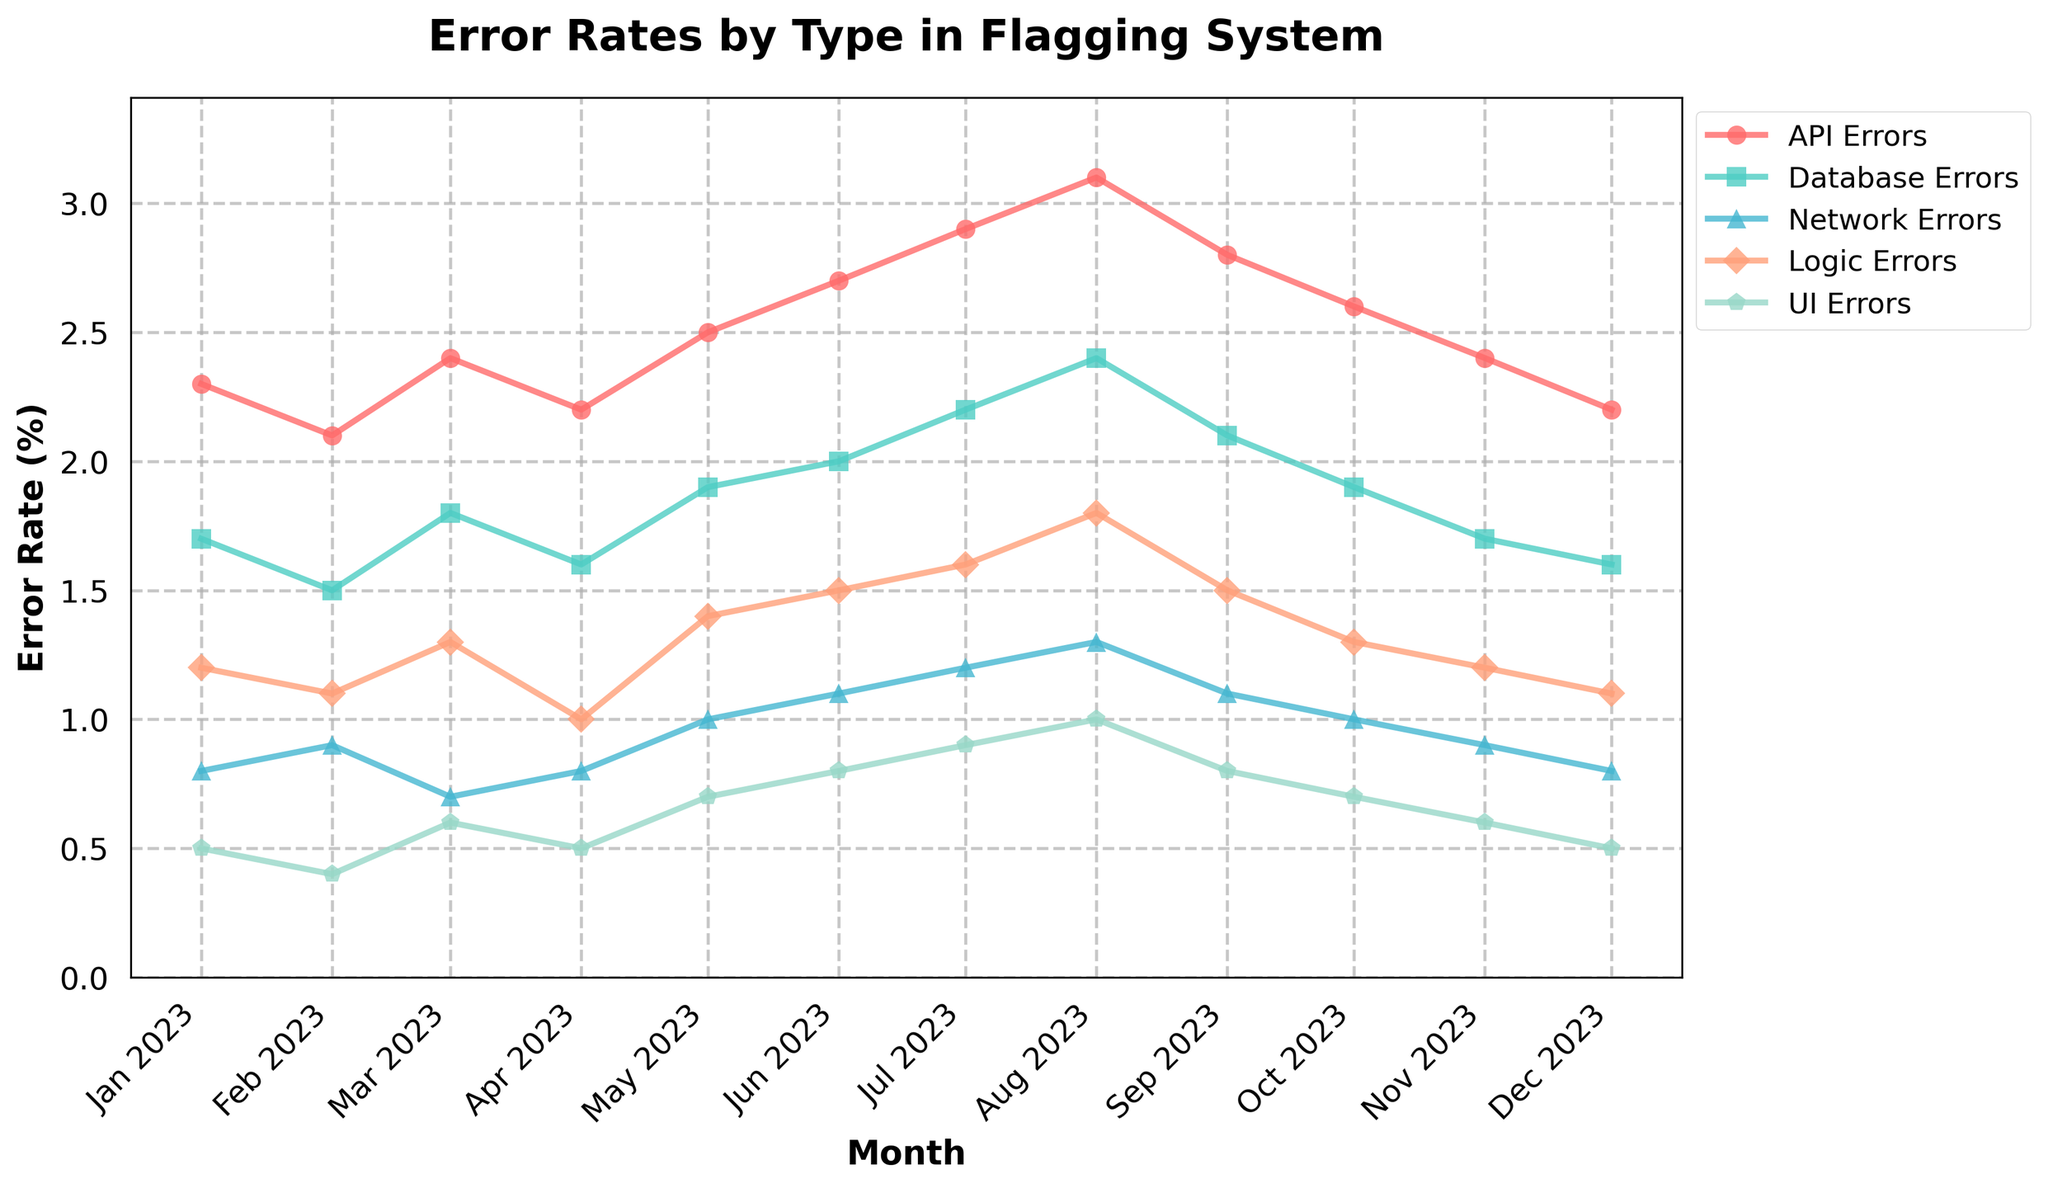How many types of errors are tracked in this plot? Observe the plot legend where the different types of errors are listed. There are 5 different types of errors visible: API Errors, Database Errors, Network Errors, Logic Errors, and UI Errors.
Answer: 5 Which month had the highest rate of API Errors? Look at the line that represents API Errors. Identify the peak of that line, which occurs in August 2023.
Answer: August 2023 In which month did Database Errors peak, and what was the error rate? Identify the peak point on the Database Errors line, which occurs in August 2023, and look up the corresponding value on the y-axis. The error rate was 2.4%.
Answer: August 2023, 2.4% How does the rate of Network Errors in December 2023 compare to January 2023? Look at the Network Errors line at the start and end points. Network Errors in January 2023 were 0.8% and in December 2023 were also 0.8%.
Answer: Same Which type of error has the steepest increasing trend from January 2023 to August 2023? Observe all lines from January to August. The API Errors line shows the steepest upward trend, moving from 2.3% to 3.1%.
Answer: API Errors What is the difference in error rates between Logic Errors and UI Errors in July 2023? Find the values for Logic Errors and UI Errors in July 2023 from the plot. Logic Errors were 1.6% and UI Errors were 0.9%. The difference is 1.6% - 0.9% = 0.7%.
Answer: 0.7% Which error type shows a consistent decrease after August 2023? Identify the error type lines that show a downward trend after August 2023. Both API Errors and Database Errors show a consistent decrease.
Answer: API Errors, Database Errors Calculate the average error rate of Database Errors across the entire year. Sum up all the monthly values of Database Errors and divide by 12. This is (1.7 + 1.5 + 1.8 + 1.6 + 1.9 + 2.0 + 2.2 + 2.4 + 2.1 + 1.9 + 1.7 + 1.6) / 12 = 22.4 / 12 = 1.87%.
Answer: 1.87% Which error type has the lowest error rate in October 2023? Look at the values of all error types in October 2023 and find the smallest. UI Errors had the lowest rate at 0.7%.
Answer: UI Errors What's the combined error rate of API Errors and Network Errors in June 2023? Look up the error rates for API Errors and Network Errors in June 2023 on the plot. API Errors were 2.7% and Network Errors were 1.1%. Combine them: 2.7% + 1.1% = 3.8%.
Answer: 3.8% 